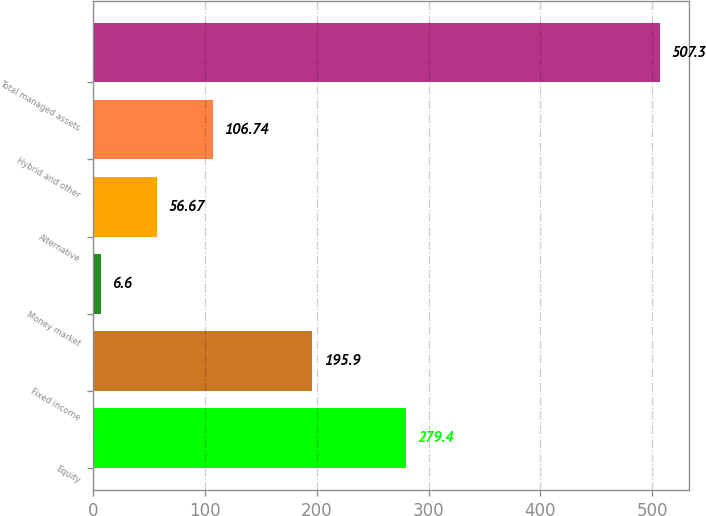Convert chart to OTSL. <chart><loc_0><loc_0><loc_500><loc_500><bar_chart><fcel>Equity<fcel>Fixed income<fcel>Money market<fcel>Alternative<fcel>Hybrid and other<fcel>Total managed assets<nl><fcel>279.4<fcel>195.9<fcel>6.6<fcel>56.67<fcel>106.74<fcel>507.3<nl></chart> 